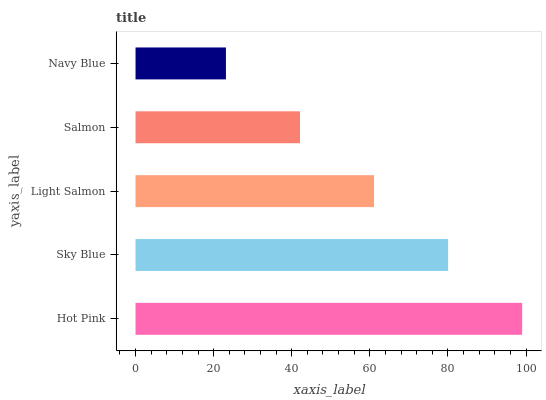Is Navy Blue the minimum?
Answer yes or no. Yes. Is Hot Pink the maximum?
Answer yes or no. Yes. Is Sky Blue the minimum?
Answer yes or no. No. Is Sky Blue the maximum?
Answer yes or no. No. Is Hot Pink greater than Sky Blue?
Answer yes or no. Yes. Is Sky Blue less than Hot Pink?
Answer yes or no. Yes. Is Sky Blue greater than Hot Pink?
Answer yes or no. No. Is Hot Pink less than Sky Blue?
Answer yes or no. No. Is Light Salmon the high median?
Answer yes or no. Yes. Is Light Salmon the low median?
Answer yes or no. Yes. Is Salmon the high median?
Answer yes or no. No. Is Sky Blue the low median?
Answer yes or no. No. 